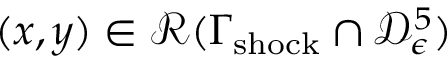<formula> <loc_0><loc_0><loc_500><loc_500>( x , y ) \in \mathcal { R } ( \Gamma _ { s h o c k } \cap \mathcal { D } _ { \epsilon } ^ { 5 } )</formula> 